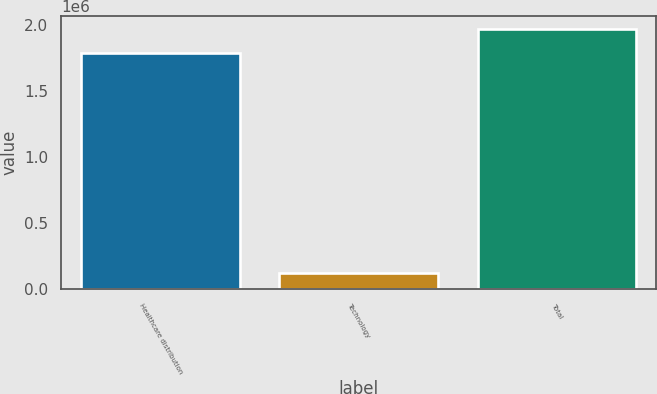<chart> <loc_0><loc_0><loc_500><loc_500><bar_chart><fcel>Healthcare distribution<fcel>Technology<fcel>Total<nl><fcel>1.79252e+06<fcel>124304<fcel>1.97177e+06<nl></chart> 